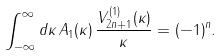<formula> <loc_0><loc_0><loc_500><loc_500>\int _ { - \infty } ^ { \infty } d \kappa \, A _ { 1 } ( \kappa ) \, \frac { V _ { 2 n + 1 } ^ { ( 1 ) } ( \kappa ) } { \kappa } = ( - 1 ) ^ { n } .</formula> 